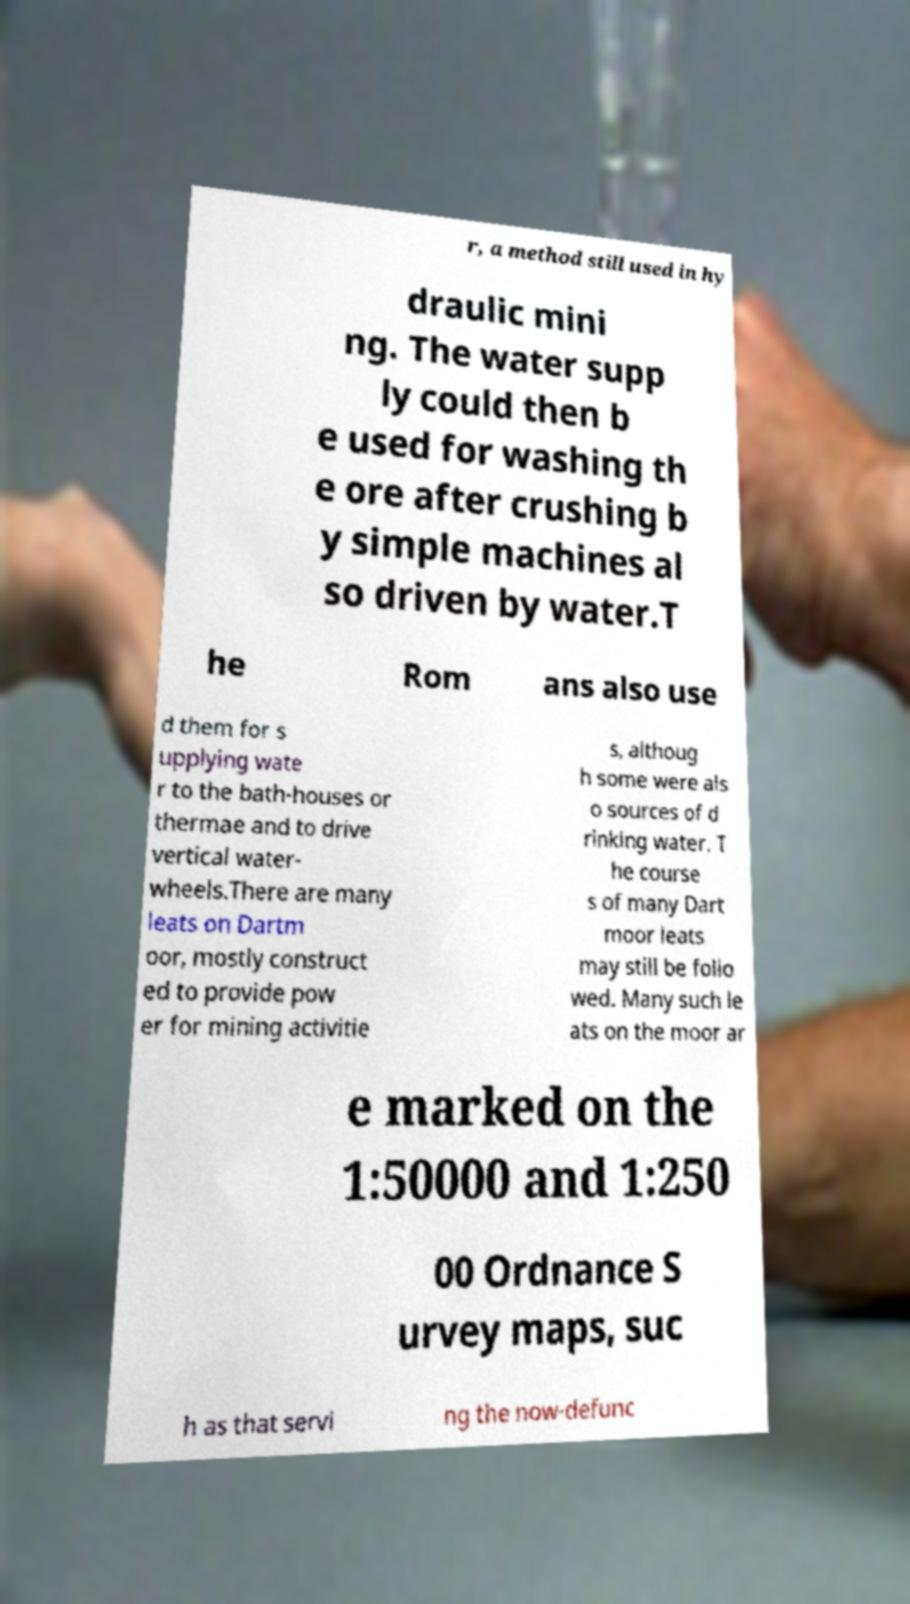Please identify and transcribe the text found in this image. r, a method still used in hy draulic mini ng. The water supp ly could then b e used for washing th e ore after crushing b y simple machines al so driven by water.T he Rom ans also use d them for s upplying wate r to the bath-houses or thermae and to drive vertical water- wheels.There are many leats on Dartm oor, mostly construct ed to provide pow er for mining activitie s, althoug h some were als o sources of d rinking water. T he course s of many Dart moor leats may still be follo wed. Many such le ats on the moor ar e marked on the 1:50000 and 1:250 00 Ordnance S urvey maps, suc h as that servi ng the now-defunc 